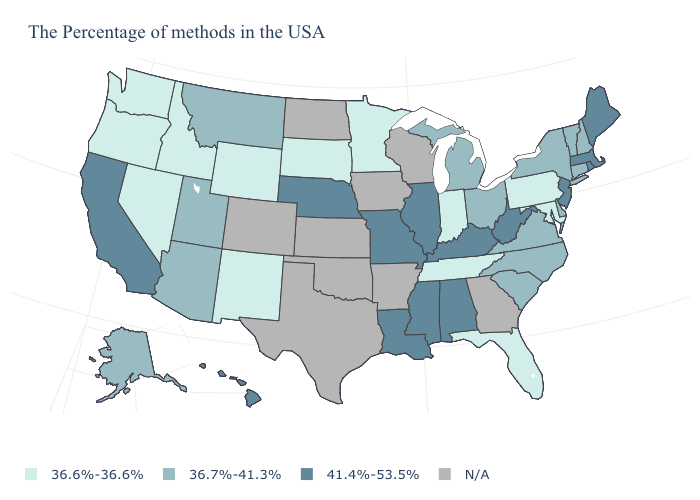Name the states that have a value in the range 36.7%-41.3%?
Answer briefly. New Hampshire, Vermont, Connecticut, New York, Delaware, Virginia, North Carolina, South Carolina, Ohio, Michigan, Utah, Montana, Arizona, Alaska. Among the states that border Montana , which have the highest value?
Answer briefly. South Dakota, Wyoming, Idaho. Name the states that have a value in the range 41.4%-53.5%?
Give a very brief answer. Maine, Massachusetts, Rhode Island, New Jersey, West Virginia, Kentucky, Alabama, Illinois, Mississippi, Louisiana, Missouri, Nebraska, California, Hawaii. Name the states that have a value in the range 36.7%-41.3%?
Short answer required. New Hampshire, Vermont, Connecticut, New York, Delaware, Virginia, North Carolina, South Carolina, Ohio, Michigan, Utah, Montana, Arizona, Alaska. What is the value of Iowa?
Answer briefly. N/A. What is the lowest value in states that border Delaware?
Concise answer only. 36.6%-36.6%. Name the states that have a value in the range 36.6%-36.6%?
Write a very short answer. Maryland, Pennsylvania, Florida, Indiana, Tennessee, Minnesota, South Dakota, Wyoming, New Mexico, Idaho, Nevada, Washington, Oregon. Among the states that border Pennsylvania , which have the highest value?
Answer briefly. New Jersey, West Virginia. Name the states that have a value in the range 36.6%-36.6%?
Short answer required. Maryland, Pennsylvania, Florida, Indiana, Tennessee, Minnesota, South Dakota, Wyoming, New Mexico, Idaho, Nevada, Washington, Oregon. What is the value of Alabama?
Keep it brief. 41.4%-53.5%. Name the states that have a value in the range N/A?
Write a very short answer. Georgia, Wisconsin, Arkansas, Iowa, Kansas, Oklahoma, Texas, North Dakota, Colorado. Name the states that have a value in the range 36.7%-41.3%?
Be succinct. New Hampshire, Vermont, Connecticut, New York, Delaware, Virginia, North Carolina, South Carolina, Ohio, Michigan, Utah, Montana, Arizona, Alaska. What is the value of Wyoming?
Answer briefly. 36.6%-36.6%. Among the states that border New Jersey , does Delaware have the lowest value?
Give a very brief answer. No. 